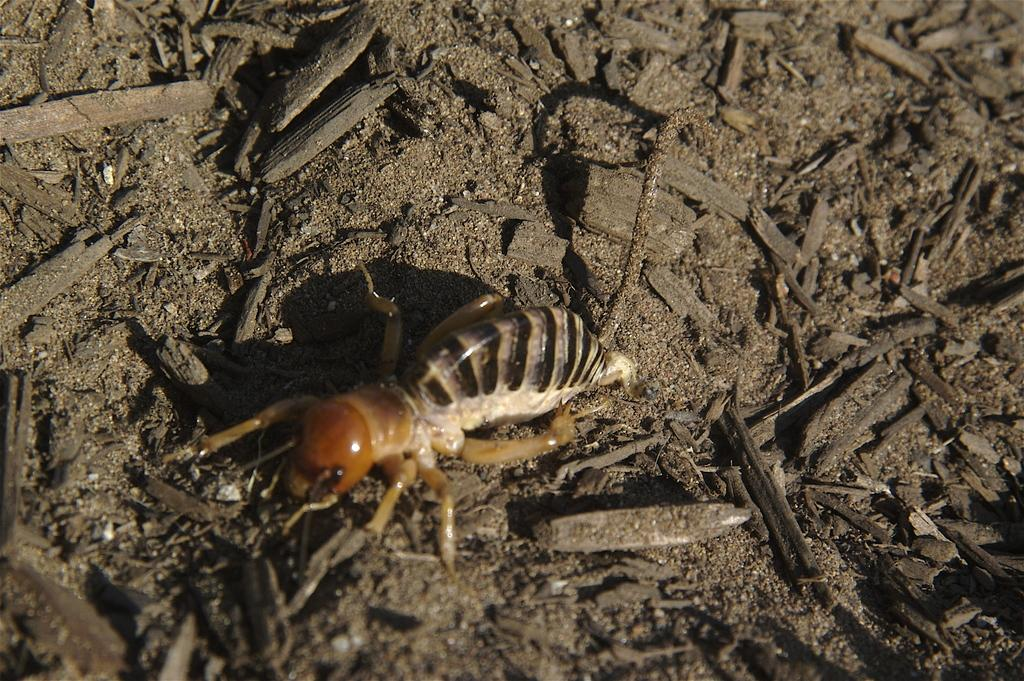Where was the image most likely taken? The image was likely taken outside. What is the main subject of the image? There is an insect in the center of the image. What is the insect doing in the image? The insect appears to be walking on the ground. What else can be seen in the image besides the insect? There are objects lying on the ground in the image. What type of horn can be seen on the pig in the image? There is no pig or horn present in the image; it features an insect walking on the ground. How many chairs are visible in the image? There are no chairs visible in the image; it features an insect walking on the ground and objects lying on the ground. 